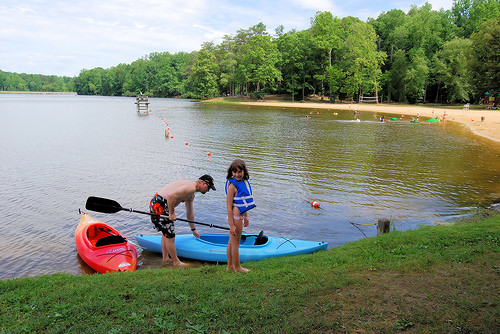<image>
Is there a man in front of the girl? No. The man is not in front of the girl. The spatial positioning shows a different relationship between these objects. 